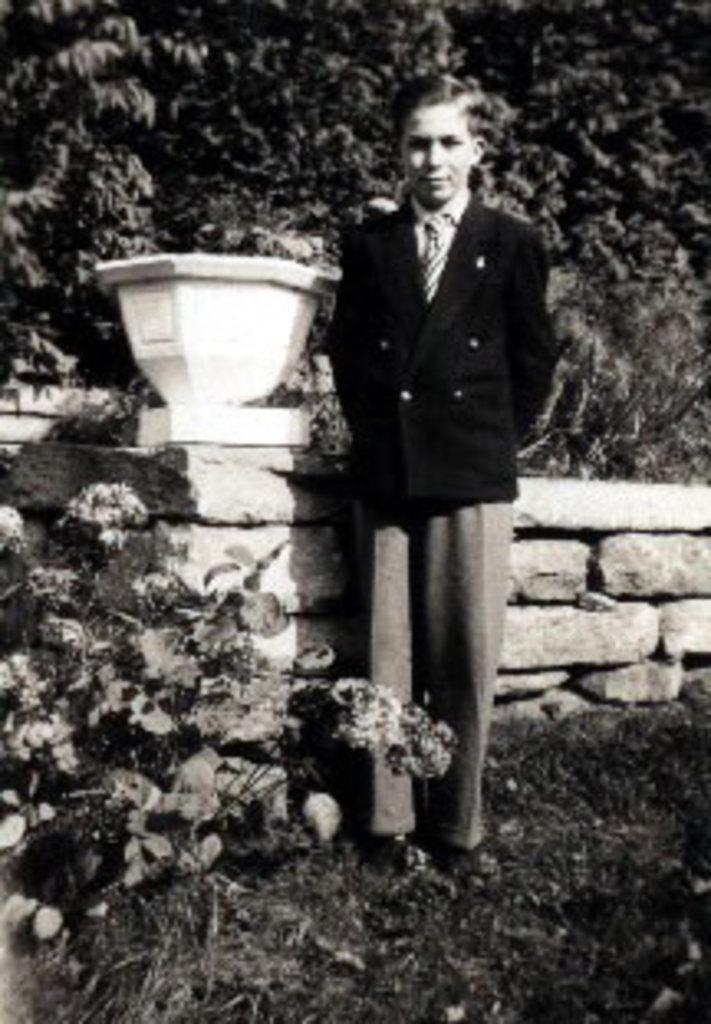In one or two sentences, can you explain what this image depicts? This is a black and white picture and in this picture we can see a man wore a blazer, tie and standing on the ground, pot, flowers and in the background we can see trees. 